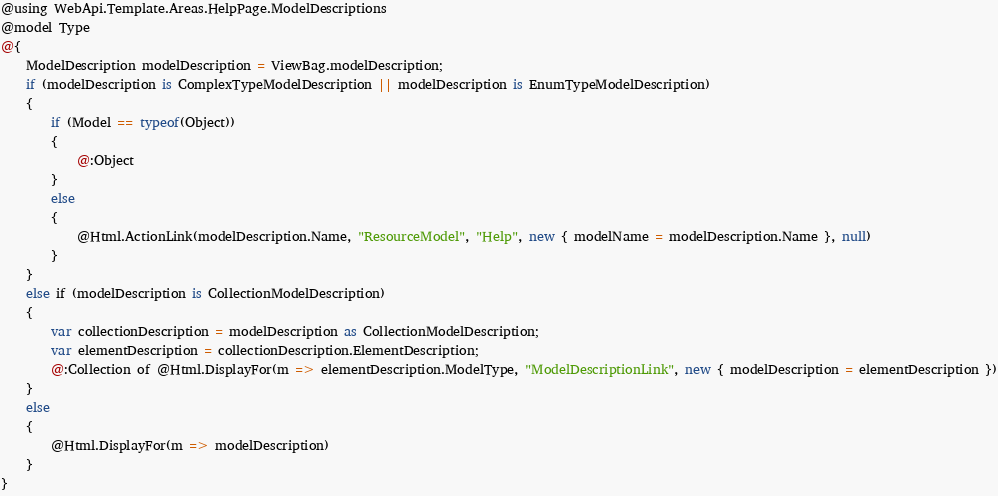Convert code to text. <code><loc_0><loc_0><loc_500><loc_500><_C#_>@using WebApi.Template.Areas.HelpPage.ModelDescriptions
@model Type
@{
    ModelDescription modelDescription = ViewBag.modelDescription;
    if (modelDescription is ComplexTypeModelDescription || modelDescription is EnumTypeModelDescription)
    {
        if (Model == typeof(Object))
        {
            @:Object
        }
        else
        {
            @Html.ActionLink(modelDescription.Name, "ResourceModel", "Help", new { modelName = modelDescription.Name }, null)
        }
    }
    else if (modelDescription is CollectionModelDescription)
    {
        var collectionDescription = modelDescription as CollectionModelDescription;
        var elementDescription = collectionDescription.ElementDescription;
        @:Collection of @Html.DisplayFor(m => elementDescription.ModelType, "ModelDescriptionLink", new { modelDescription = elementDescription })
    }
    else
    {
        @Html.DisplayFor(m => modelDescription)
    }
}</code> 